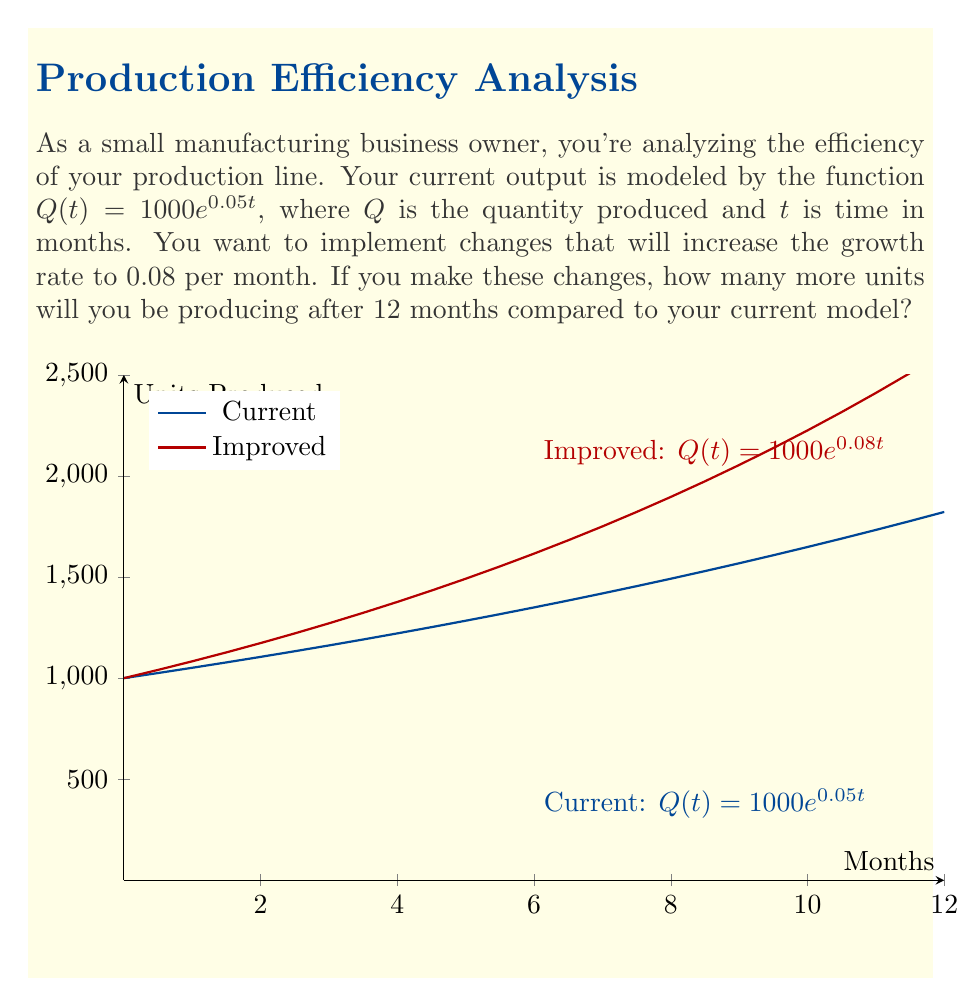Give your solution to this math problem. Let's approach this step-by-step:

1) Current model: $Q_1(t) = 1000e^{0.05t}$
   Improved model: $Q_2(t) = 1000e^{0.08t}$

2) We need to calculate the difference after 12 months:
   $\Delta Q = Q_2(12) - Q_1(12)$

3) Let's calculate $Q_1(12)$:
   $Q_1(12) = 1000e^{0.05 \cdot 12} = 1000e^{0.6} \approx 1822.12$

4) Now calculate $Q_2(12)$:
   $Q_2(12) = 1000e^{0.08 \cdot 12} = 1000e^{0.96} \approx 2611.69$

5) The difference is:
   $\Delta Q = Q_2(12) - Q_1(12) = 2611.69 - 1822.12 \approx 789.57$

6) Rounding to the nearest whole unit (as we can't produce partial units):
   $\Delta Q \approx 790$ units
Answer: 790 units 